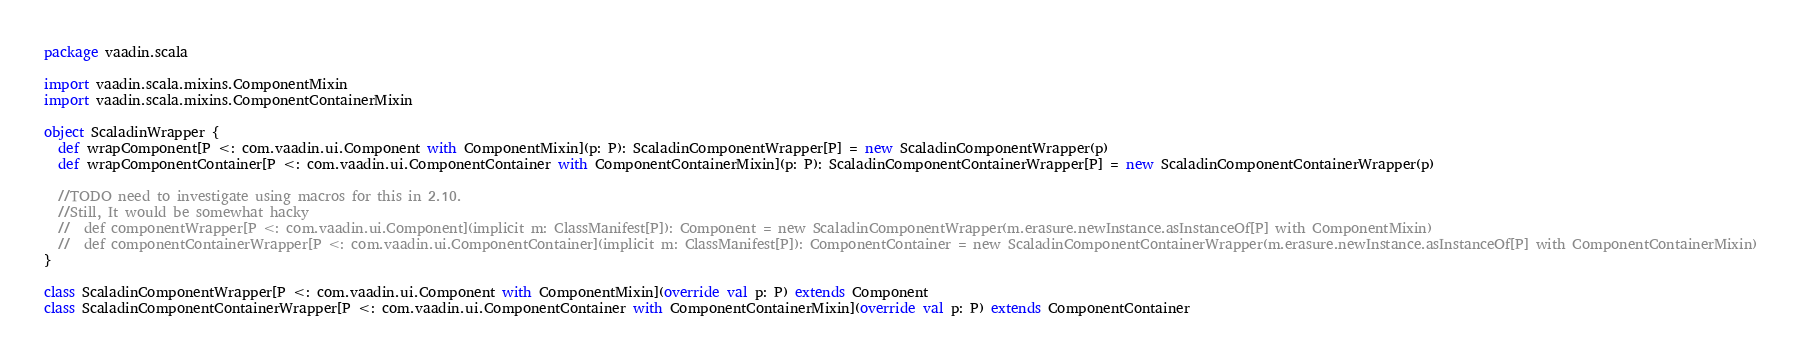<code> <loc_0><loc_0><loc_500><loc_500><_Scala_>package vaadin.scala

import vaadin.scala.mixins.ComponentMixin
import vaadin.scala.mixins.ComponentContainerMixin

object ScaladinWrapper {
  def wrapComponent[P <: com.vaadin.ui.Component with ComponentMixin](p: P): ScaladinComponentWrapper[P] = new ScaladinComponentWrapper(p)
  def wrapComponentContainer[P <: com.vaadin.ui.ComponentContainer with ComponentContainerMixin](p: P): ScaladinComponentContainerWrapper[P] = new ScaladinComponentContainerWrapper(p)

  //TODO need to investigate using macros for this in 2.10. 
  //Still, It would be somewhat hacky
  //  def componentWrapper[P <: com.vaadin.ui.Component](implicit m: ClassManifest[P]): Component = new ScaladinComponentWrapper(m.erasure.newInstance.asInstanceOf[P] with ComponentMixin)
  //  def componentContainerWrapper[P <: com.vaadin.ui.ComponentContainer](implicit m: ClassManifest[P]): ComponentContainer = new ScaladinComponentContainerWrapper(m.erasure.newInstance.asInstanceOf[P] with ComponentContainerMixin)
}

class ScaladinComponentWrapper[P <: com.vaadin.ui.Component with ComponentMixin](override val p: P) extends Component
class ScaladinComponentContainerWrapper[P <: com.vaadin.ui.ComponentContainer with ComponentContainerMixin](override val p: P) extends ComponentContainer</code> 